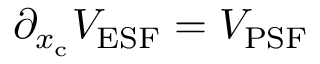Convert formula to latex. <formula><loc_0><loc_0><loc_500><loc_500>\partial _ { x _ { c } } V _ { E S F } = V _ { P S F }</formula> 